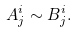<formula> <loc_0><loc_0><loc_500><loc_500>A ^ { i } _ { j } \sim B ^ { i } _ { j } .</formula> 